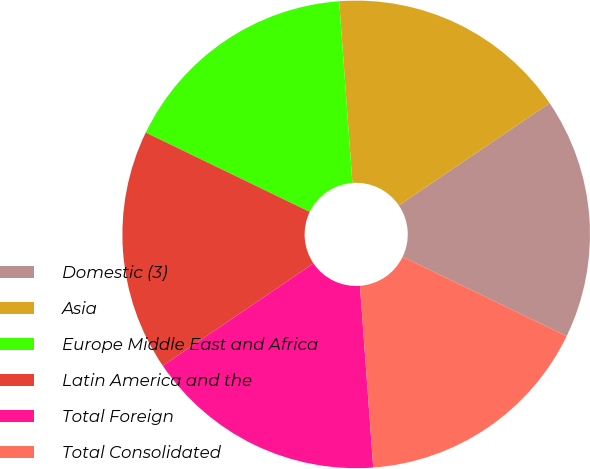Convert chart. <chart><loc_0><loc_0><loc_500><loc_500><pie_chart><fcel>Domestic (3)<fcel>Asia<fcel>Europe Middle East and Africa<fcel>Latin America and the<fcel>Total Foreign<fcel>Total Consolidated<nl><fcel>16.66%<fcel>16.67%<fcel>16.67%<fcel>16.67%<fcel>16.67%<fcel>16.67%<nl></chart> 